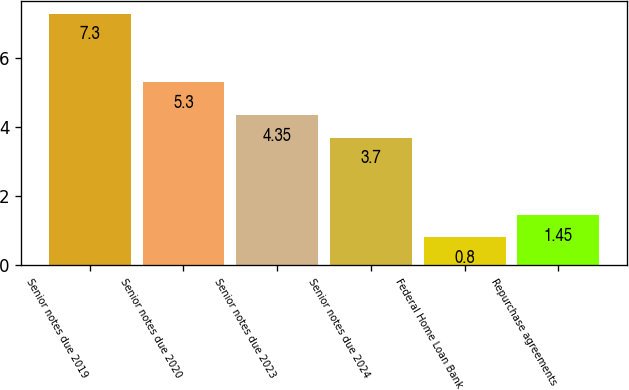Convert chart to OTSL. <chart><loc_0><loc_0><loc_500><loc_500><bar_chart><fcel>Senior notes due 2019<fcel>Senior notes due 2020<fcel>Senior notes due 2023<fcel>Senior notes due 2024<fcel>Federal Home Loan Bank<fcel>Repurchase agreements<nl><fcel>7.3<fcel>5.3<fcel>4.35<fcel>3.7<fcel>0.8<fcel>1.45<nl></chart> 